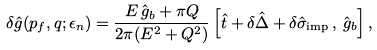Convert formula to latex. <formula><loc_0><loc_0><loc_500><loc_500>\delta \hat { g } ( { p } _ { f } , { q } ; \epsilon _ { n } ) = \frac { E \, \hat { g } _ { b } + \pi Q } { 2 \pi ( E ^ { 2 } + Q ^ { 2 } ) } \left [ \hat { t } + \delta \hat { \Delta } + \delta \hat { \sigma } _ { \text {imp} } \, , \, \hat { g } _ { b } \right ] ,</formula> 